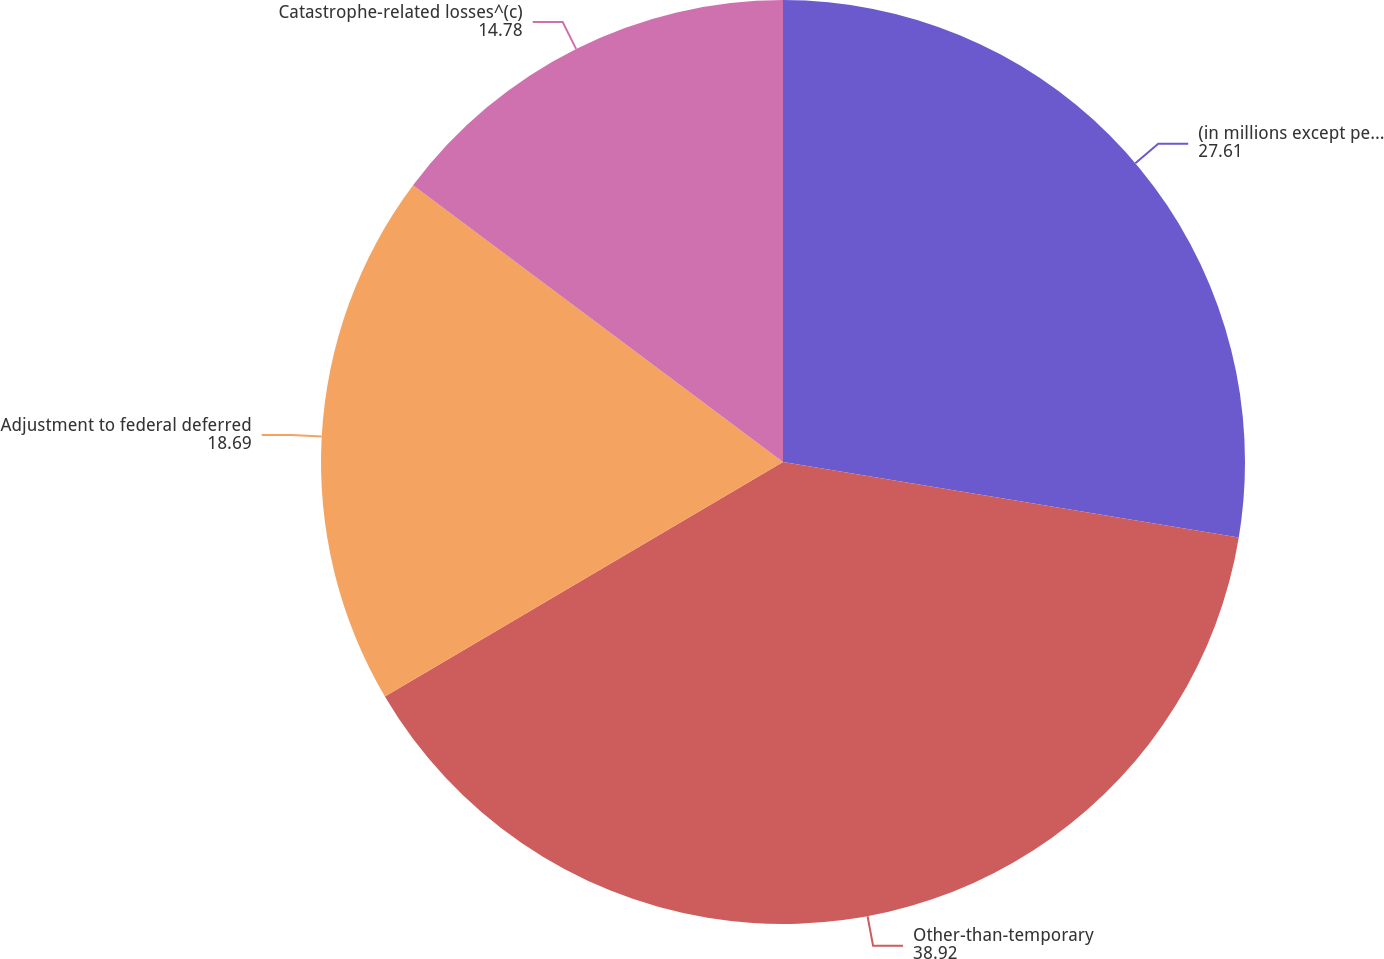Convert chart. <chart><loc_0><loc_0><loc_500><loc_500><pie_chart><fcel>(in millions except per share<fcel>Other-than-temporary<fcel>Adjustment to federal deferred<fcel>Catastrophe-related losses^(c)<nl><fcel>27.61%<fcel>38.92%<fcel>18.69%<fcel>14.78%<nl></chart> 